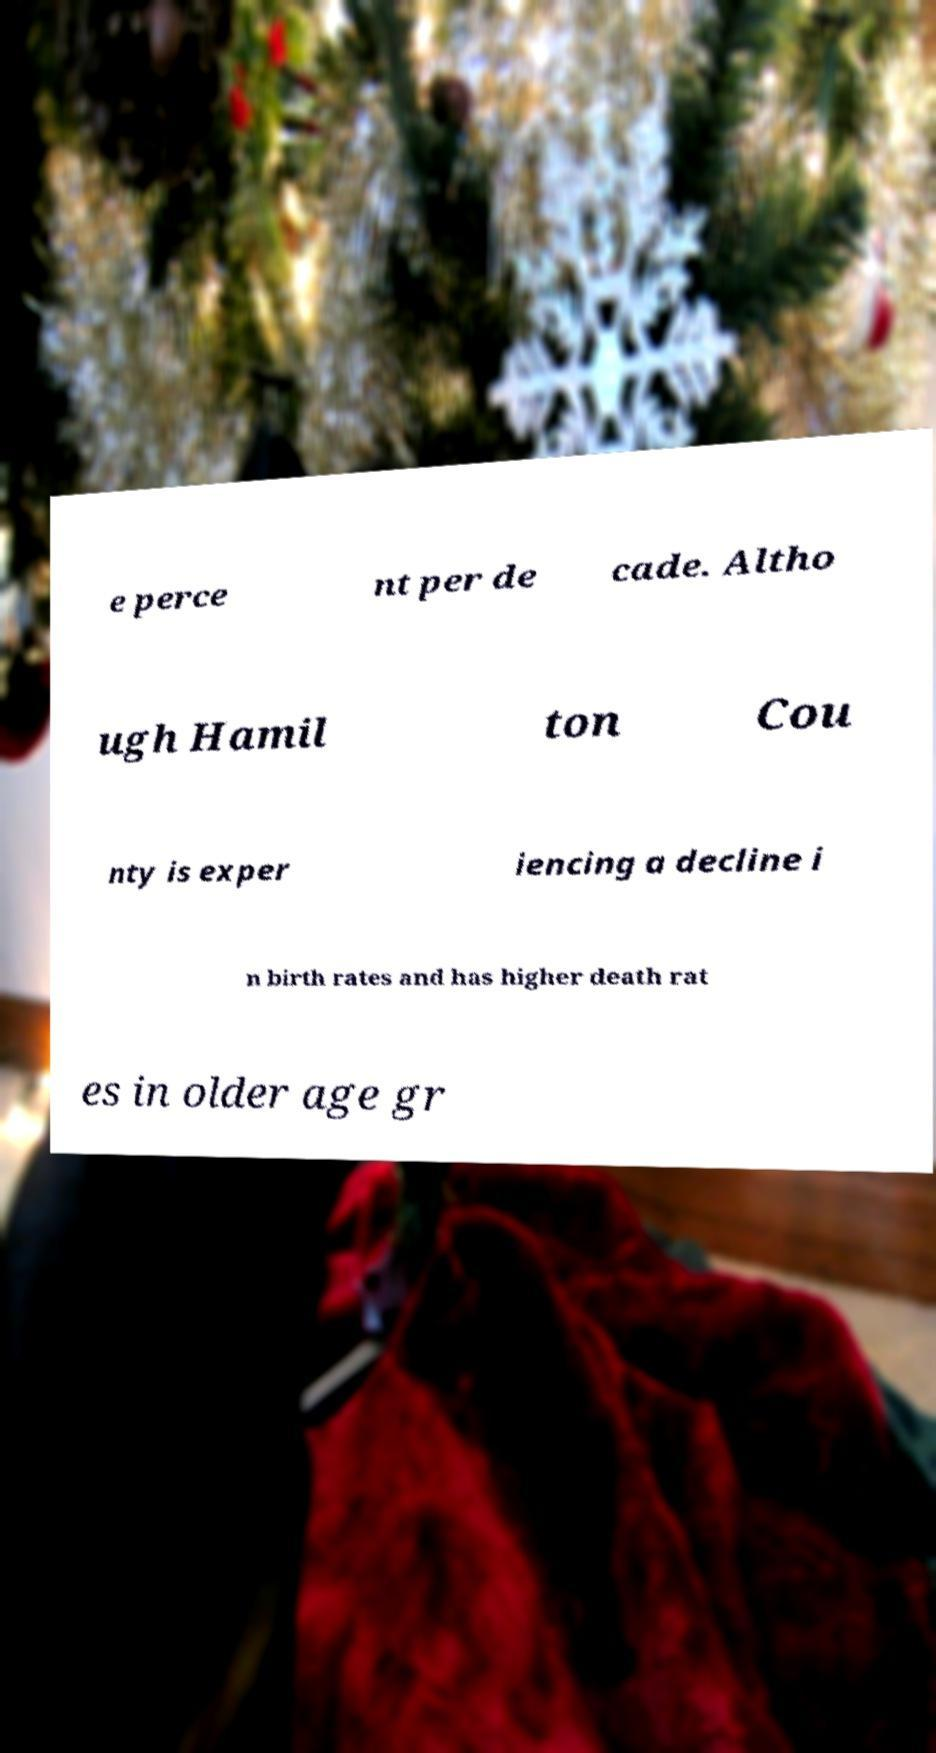Can you accurately transcribe the text from the provided image for me? e perce nt per de cade. Altho ugh Hamil ton Cou nty is exper iencing a decline i n birth rates and has higher death rat es in older age gr 